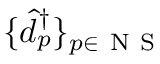<formula> <loc_0><loc_0><loc_500><loc_500>\{ \hat { d } _ { p } ^ { \dagger } \} _ { p \in { N S } }</formula> 